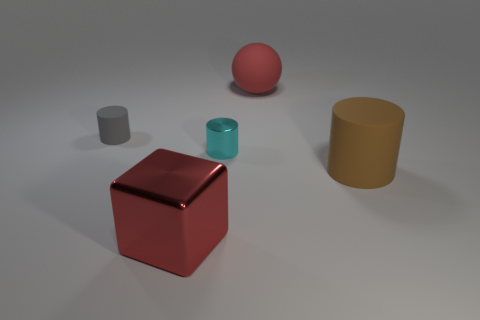Add 3 cyan blocks. How many objects exist? 8 Subtract all spheres. How many objects are left? 4 Subtract all green metal objects. Subtract all gray objects. How many objects are left? 4 Add 5 big brown objects. How many big brown objects are left? 6 Add 5 big brown cylinders. How many big brown cylinders exist? 6 Subtract 0 gray cubes. How many objects are left? 5 